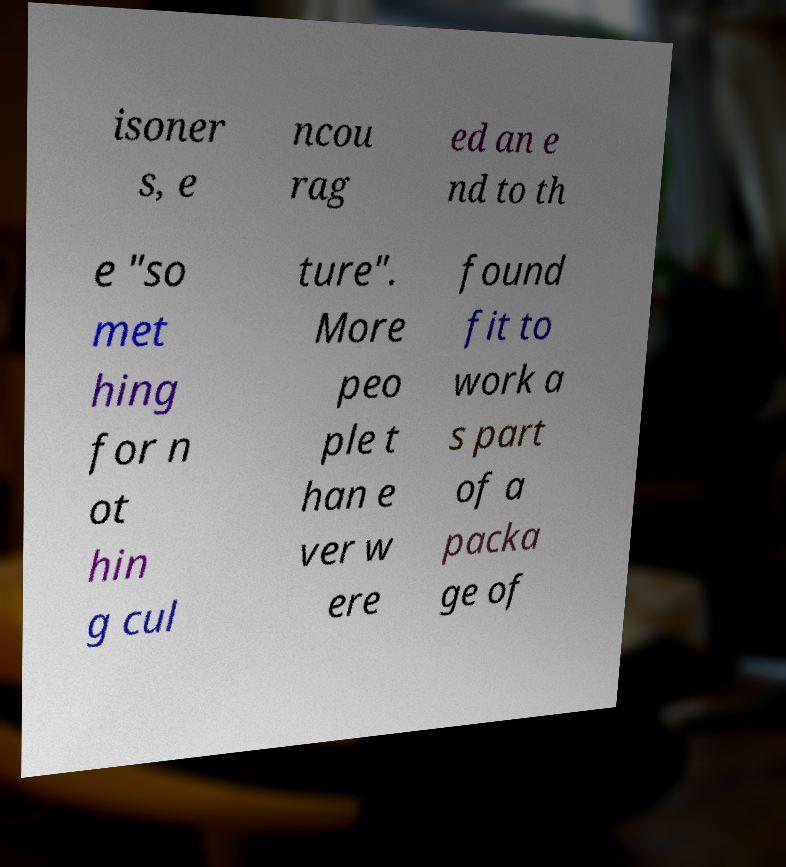Please identify and transcribe the text found in this image. isoner s, e ncou rag ed an e nd to th e "so met hing for n ot hin g cul ture". More peo ple t han e ver w ere found fit to work a s part of a packa ge of 